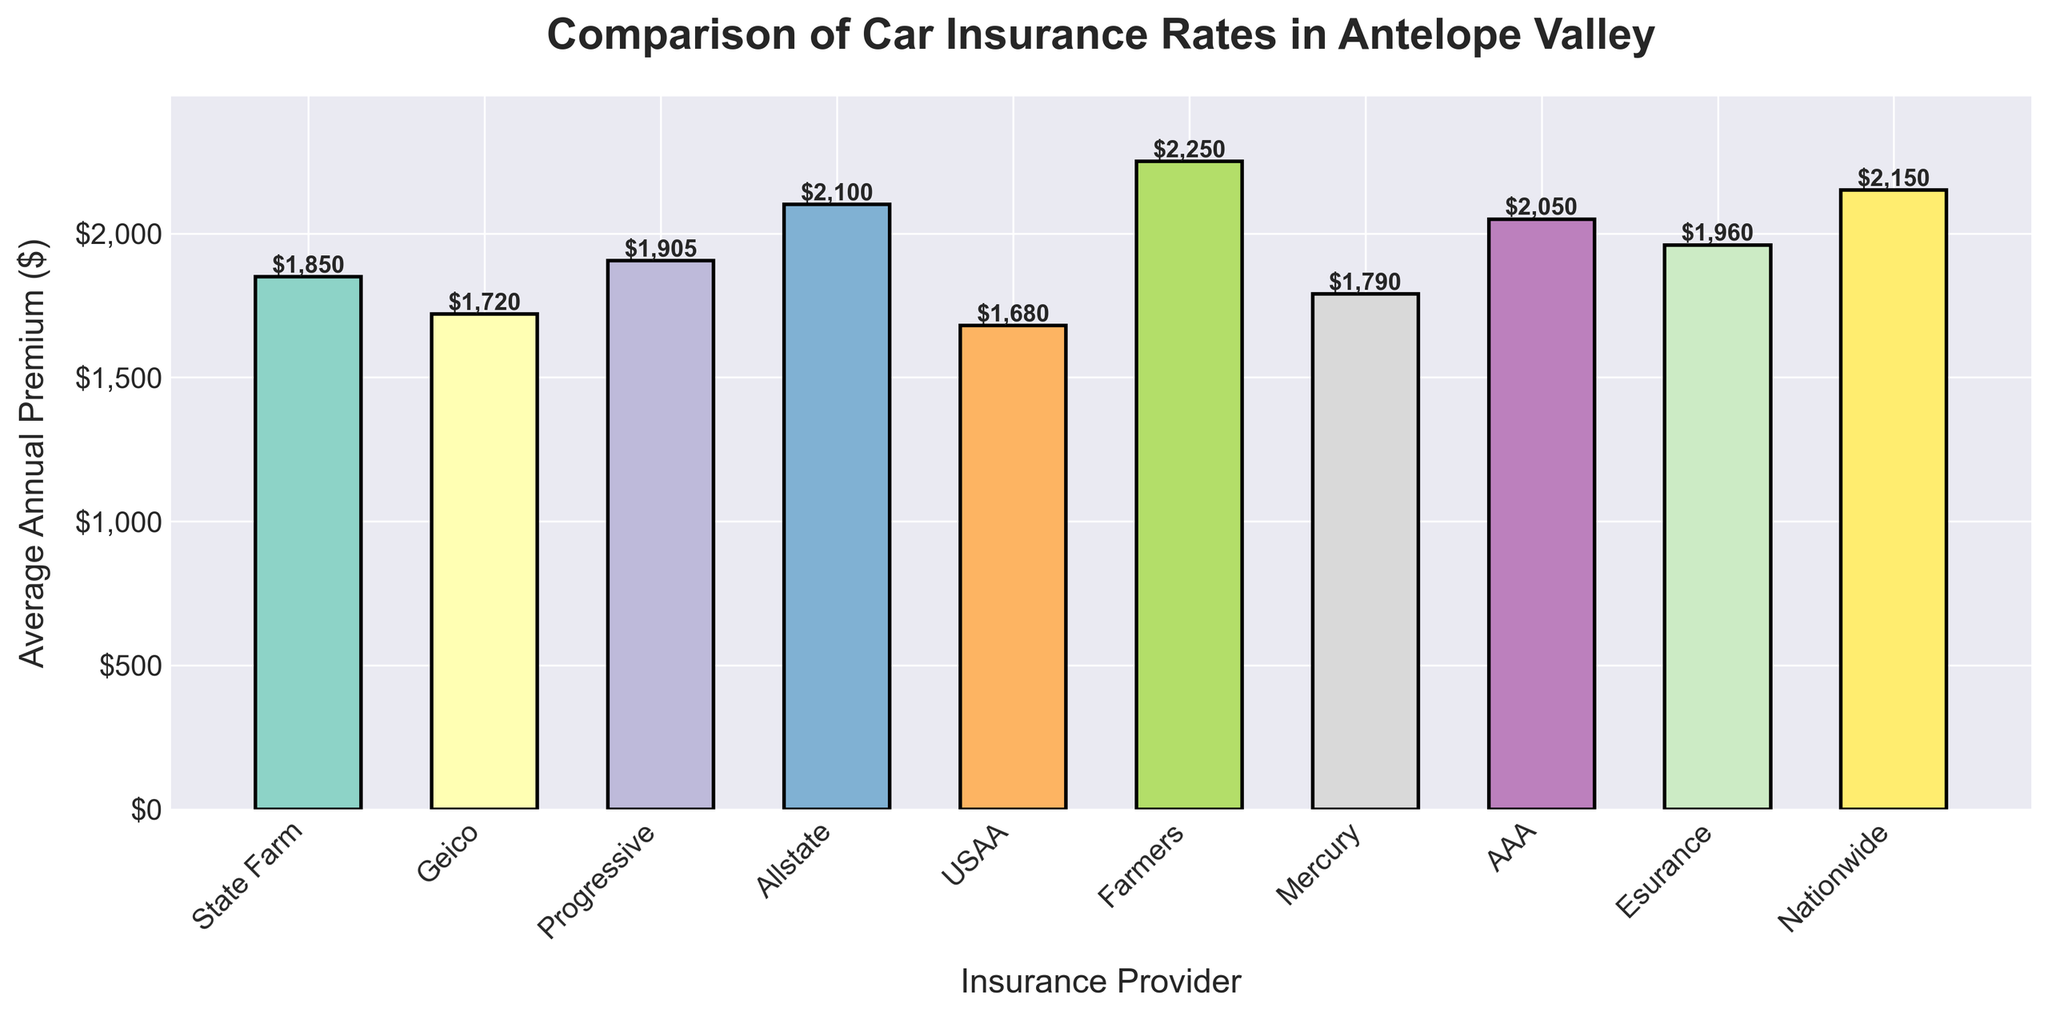What is the most expensive insurance provider in the chart? Look at the tallest bar in the chart. The insurance provider with the highest average annual premium is the most expensive. The tallest bar corresponds to Farmers with an average annual premium of $2,250
Answer: Farmers Which insurance provider has the lowest average annual premium? Identify the shortest bar in the chart. The insurance provider with the lowest average annual premium is USAA with a premium of $1,680
Answer: USAA What is the difference in average annual premium between Geico and Allstate? Find the bars for Geico and Allstate. Geico has an average premium of $1,720, and Allstate has $2,100. The difference is $2,100 - $1,720 = $380
Answer: $380 How many insurance providers have an average annual premium above $2,000? Count the bars that exceed the $2,000 mark. There are four providers: Allstate, Farmers, AAA, and Nationwide
Answer: 4 What is the average annual premium across all the insurance providers listed? Sum up all the average annual premiums and divide by the number of providers. The sum is $1850 + $1720 + $1905 + $2100 + $1680 + $2250 + $1790 + $2050 + $1960 + $2150 = $19455. The average is $19,455 / 10 = $1,945.5
Answer: $1,945.5 Is Mercury's average annual premium higher or lower than the average for all the providers? Compare Mercury's average premium ($1,790) to the overall average ($1,945.5). Mercury's premium is lower
Answer: Lower Which bars represent providers with an average annual premium less than $1,800? Observe the bars below the $1,800 mark. Geico, USAA, and Mercury fall into this category with premiums of $1,720, $1,680, and $1,790 respectively
Answer: Geico, USAA, Mercury What is the total of the average annual premiums for State Farm, Progressive, and Esurance? Find the premiums for State Farm ($1,850), Progressive ($1,905), and Esurance ($1,960). Add them up: $1,850 + $1,905 + $1,960 = $5,715
Answer: $5,715 Which insurance provider has a premium closest to $2,000? Identify the bar closest to the $2,000 mark. AAA has a premium of $2,050, which is closest to $2,000
Answer: AAA What is the range of the average annual premiums among the insurance providers? Subtract the lowest premium (USAA, $1,680) from the highest premium (Farmers, $2,250). The range is $2,250 - $1,680 = $570
Answer: $570 